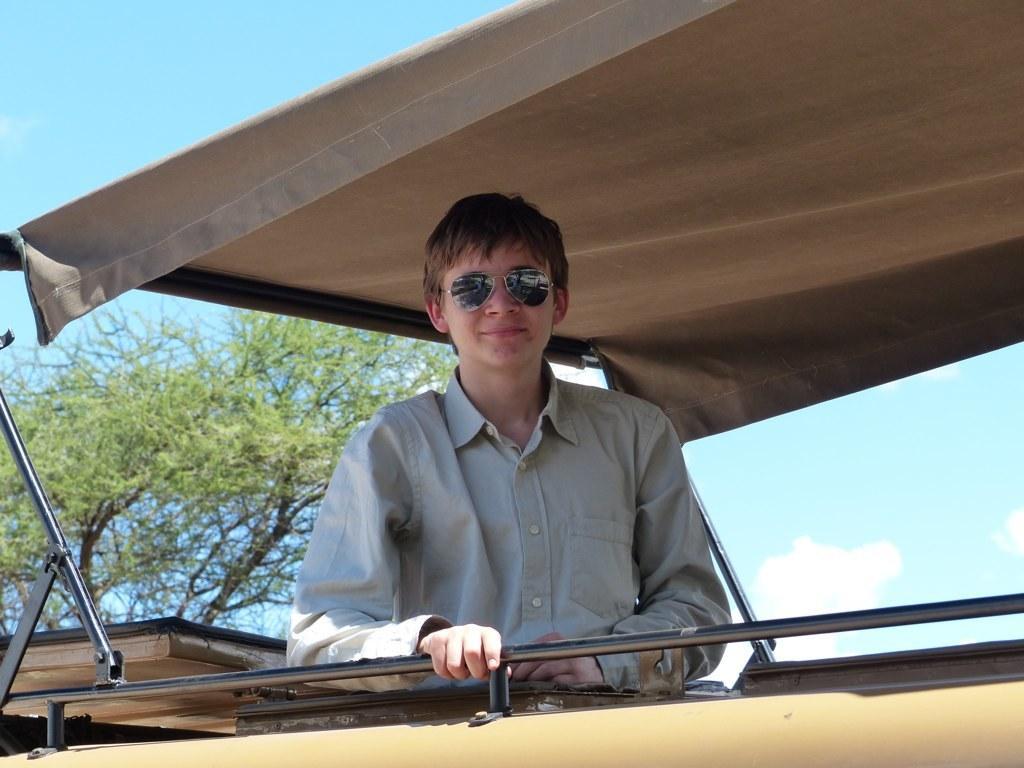Can you describe this image briefly? In the center of the image we can see a person wearing glasses and the person is present under the roof. In the background we can see the trees and also the sky with some clouds. 